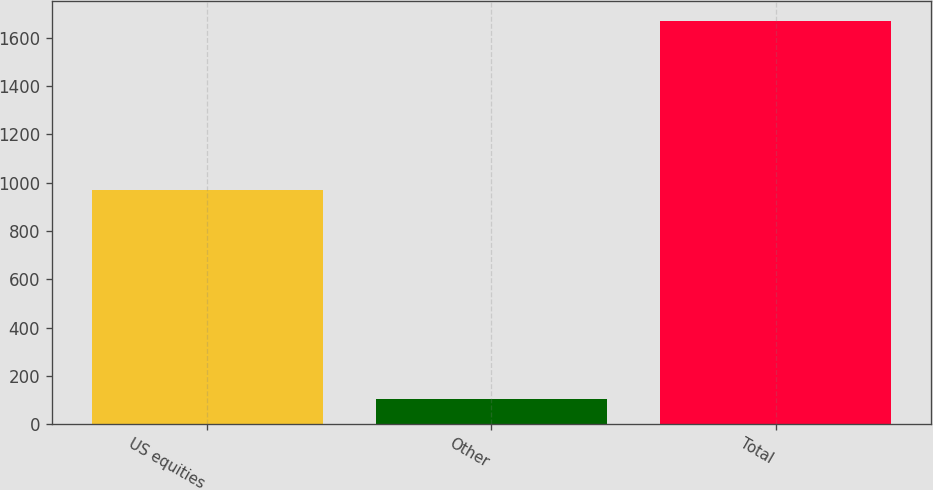<chart> <loc_0><loc_0><loc_500><loc_500><bar_chart><fcel>US equities<fcel>Other<fcel>Total<nl><fcel>968<fcel>107<fcel>1670<nl></chart> 